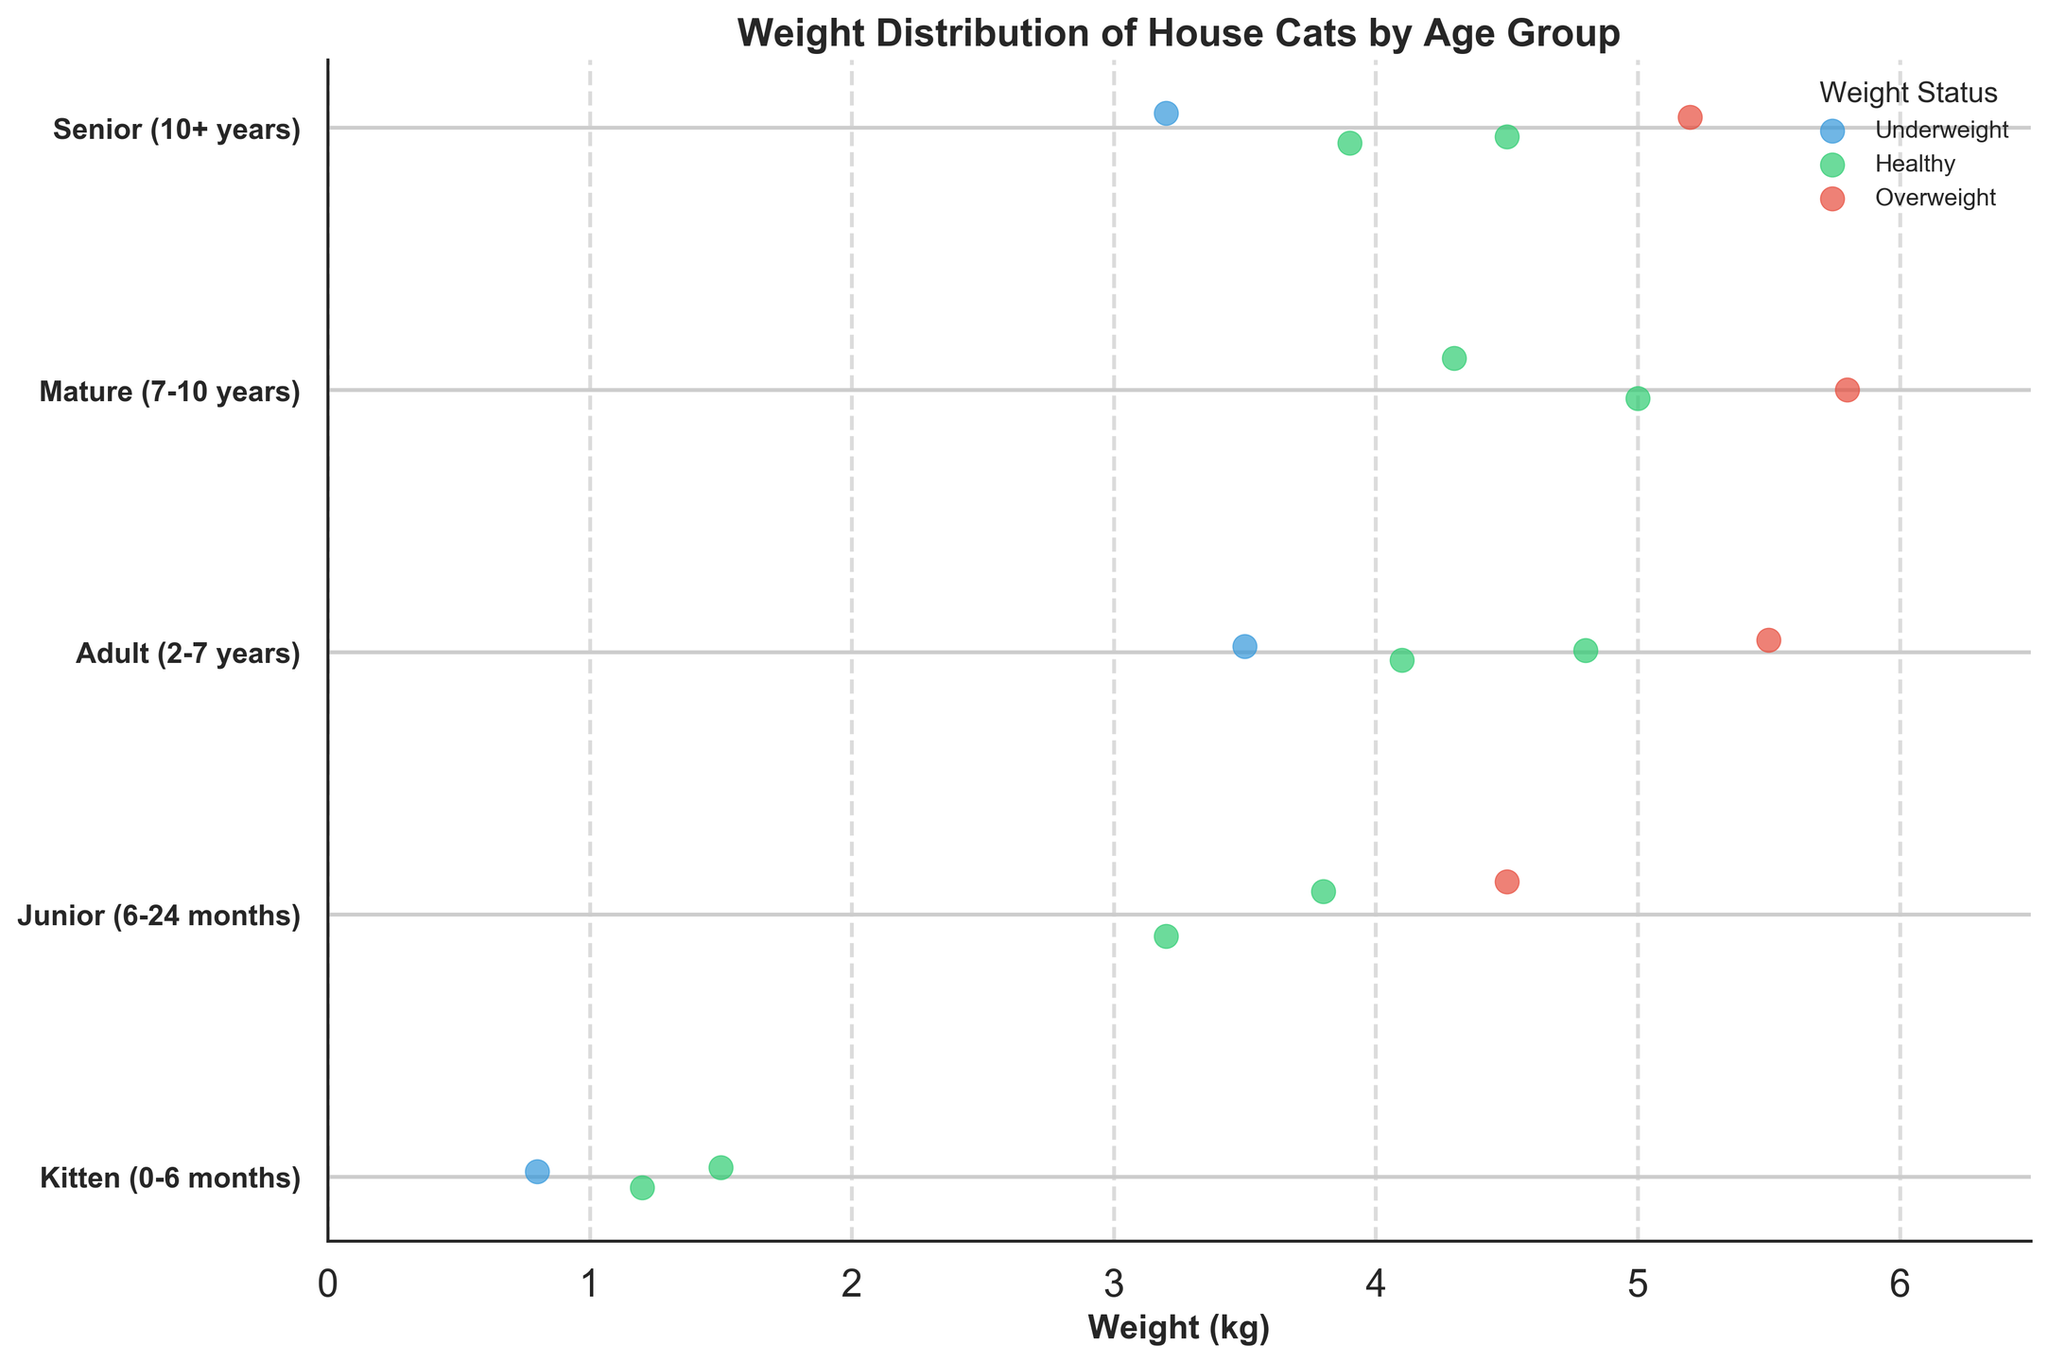What is the title of the figure? Look at the top of the figure where the title is usually located. The title is "Weight Distribution of House Cats by Age Group".
Answer: Weight Distribution of House Cats by Age Group What color represents healthy weight status in the plot? Observe the legend on the plot. Green color is associated with healthy weight status according to the legend.
Answer: Green How many age groups are represented in the plot? The y-axis has tick labels that represent the age groups. Counting these labels gives 5 age groups.
Answer: 5 Which age group has the highest number of overweight cats? Examine the scatter points for each age group. Identify the group with the most red points representing overweight cats. The Adult and Senior groups each have 1 overweight cat.
Answer: Adult, Senior What is the weight range for healthy weights in the "Junior (6-24 months)" age group? Look at the green dots in the Junior age group and identify their minimum and maximum weights. The weights are 3.2 kg and 3.8 kg.
Answer: 3.2 kg - 3.8 kg How does the number of healthy weight cats in the "Kitten (0-6 months)" group compare to the "Senior (10+ years)" group? Count the green dots representing healthy weights in both groups. Kitten has 2 healthy cats, Senior has 2 as well.
Answer: Equal What is the average weight of cats in the "Adult (2-7 years)" age group? Identify the weights in the Adult group: 4.1, 4.8, 5.5, and 3.5 kg. Sum these weights and divide by the number of weights (4). Sum = 17.9 kg, average = 17.9 / 4 = 4.475 kg.
Answer: 4.475 kg Is there any age group without overweight or underweight cats? Scan the plot for each age group and check if all the cats are within the healthy weight range. The Kitten, Junior, Adult, and Senior groups have at least one overweight or underweight cat, while Mature has only healthy cats.
Answer: Mature (7-10 years) What is the weight of the underweight cat in the "Senior (10+ years)" age group? Find the blue dot in the Senior group representing the underweight status. The weight is 3.2 kg.
Answer: 3.2 kg Which age group has the broadest range of cat weights? Identify the minimum and maximum weights within each age group. The Adult group has weights ranging from 3.5 kg to 5.5 kg (range 2 kg), which is the broadest range compared to other groups.
Answer: Adult (2-7 years) 